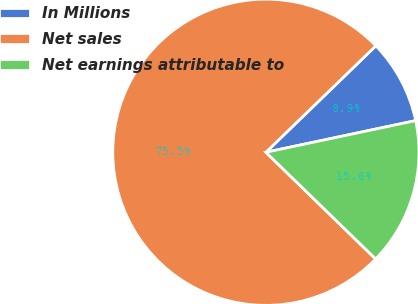Convert chart. <chart><loc_0><loc_0><loc_500><loc_500><pie_chart><fcel>In Millions<fcel>Net sales<fcel>Net earnings attributable to<nl><fcel>8.93%<fcel>75.48%<fcel>15.59%<nl></chart> 